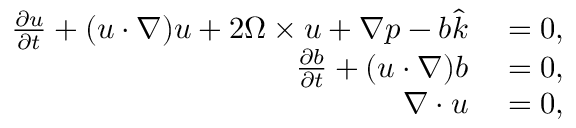<formula> <loc_0><loc_0><loc_500><loc_500>\begin{array} { r l } { \frac { \partial u } { \partial t } + ( u \cdot \nabla ) u + 2 \Omega \times u + \nabla p - b \hat { k } } & = 0 , } \\ { \frac { \partial b } { \partial t } + ( u \cdot \nabla ) b } & = 0 , } \\ { \nabla \cdot u } & = 0 , } \end{array}</formula> 